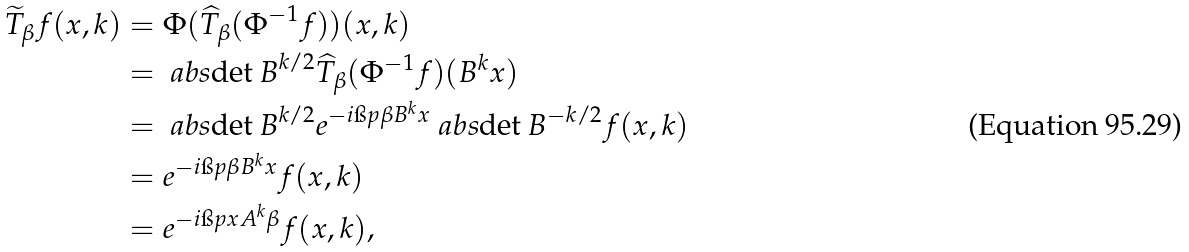Convert formula to latex. <formula><loc_0><loc_0><loc_500><loc_500>\widetilde { T } _ { \beta } f ( x , k ) & = \Phi ( \widehat { T } _ { \beta } ( \Phi ^ { - 1 } f ) ) ( x , k ) \\ & = \ a b s { \det B } ^ { k / 2 } \widehat { T } _ { \beta } ( \Phi ^ { - 1 } f ) ( B ^ { k } x ) \\ & = \ a b s { \det B } ^ { k / 2 } e ^ { - i \i p { \beta } { B ^ { k } x } } \ a b s { \det B } ^ { - k / 2 } f ( x , k ) \\ & = e ^ { - i \i p { \beta } { B ^ { k } x } } f ( x , k ) \\ & = e ^ { - i \i p { x } { A ^ { k } \beta } } f ( x , k ) \text {,}</formula> 